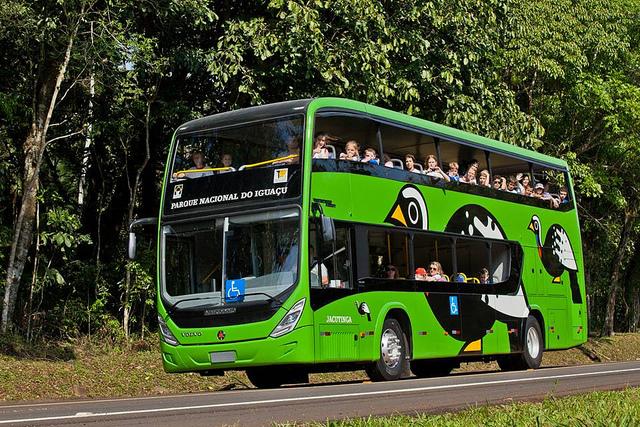How many decks does this bus have?
Keep it brief. 2. What level are the parents sitting on?
Be succinct. Bottom. What kind of animal is depicted on the side of the bus?
Answer briefly. Bird. 